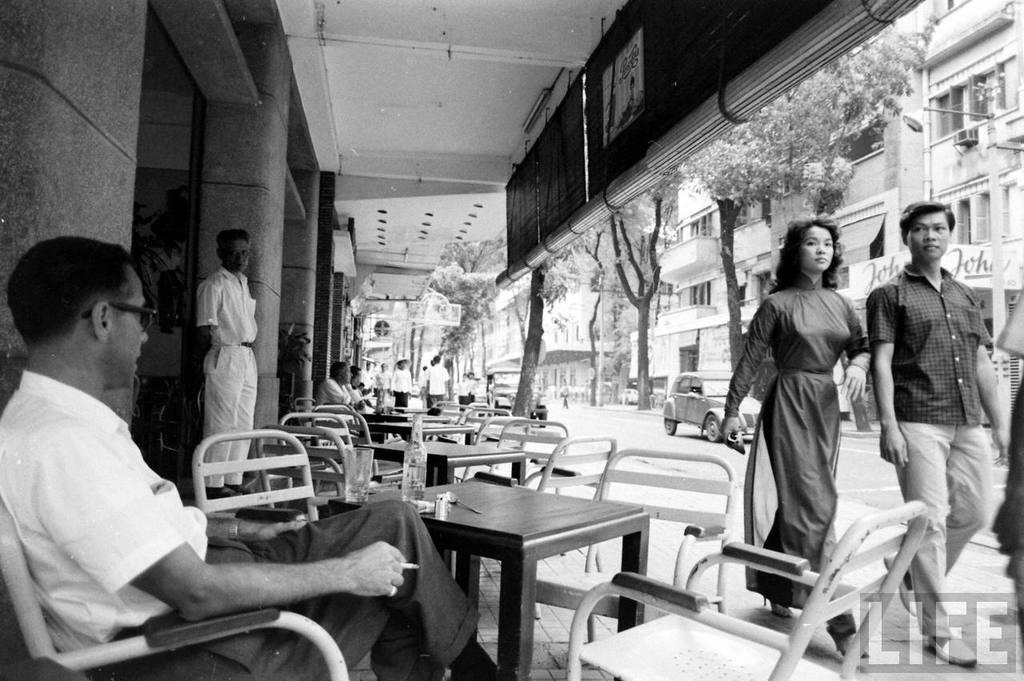Can you describe this image briefly? This picture is clicked outside the city. Here, we see man and woman are walking on the road. Behind them, we see a car moving on the road and beside that, we see a building which is white in color and we even see trees. In the middle of the picture, we see many chairs and table. On the top of the picture, we see the roof of the building and this is a black and white photo. 